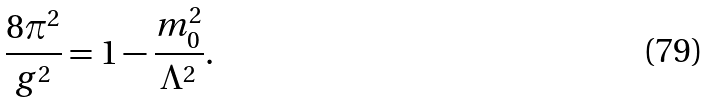<formula> <loc_0><loc_0><loc_500><loc_500>\frac { 8 \pi ^ { 2 } } { g ^ { 2 } } = 1 - \frac { m _ { 0 } ^ { 2 } } { \Lambda ^ { 2 } } .</formula> 